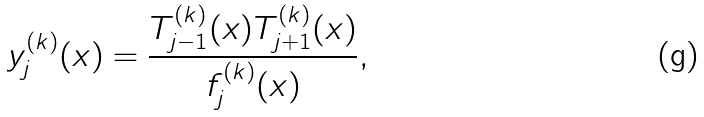Convert formula to latex. <formula><loc_0><loc_0><loc_500><loc_500>y ^ { ( k ) } _ { j } ( x ) = \frac { T ^ { ( k ) } _ { j - 1 } ( x ) T ^ { ( k ) } _ { j + 1 } ( x ) } { f ^ { ( k ) } _ { j } ( x ) } ,</formula> 